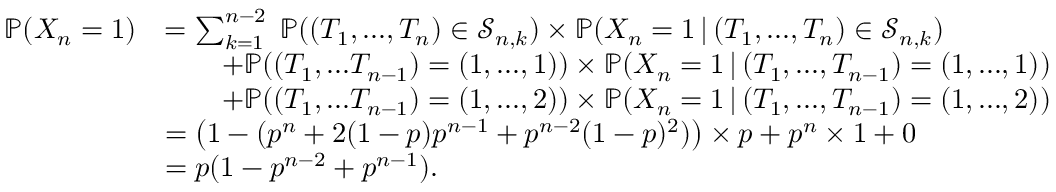<formula> <loc_0><loc_0><loc_500><loc_500>\begin{array} { r l } { \mathbb { P } ( X _ { n } = 1 ) } & { = \sum _ { k = 1 } ^ { n - 2 } \, \mathbb { P } ( ( T _ { 1 } , \dots , T _ { n } ) \in \mathcal { S } _ { n , k } ) \times \mathbb { P } ( X _ { n } = 1 \, | \, ( T _ { 1 } , \dots , T _ { n } ) \in \mathcal { S } _ { n , k } ) } \\ & { \quad + \mathbb { P } ( ( T _ { 1 } , \dots T _ { n - 1 } ) = ( 1 , \dots , 1 ) ) \times \mathbb { P } ( X _ { n } = 1 \, | \, ( T _ { 1 } , \dots , T _ { n - 1 } ) = ( 1 , \dots , 1 ) ) } \\ & { \quad + \mathbb { P } ( ( T _ { 1 } , \dots T _ { n - 1 } ) = ( 1 , \dots , 2 ) ) \times \mathbb { P } ( X _ { n } = 1 \, | \, ( T _ { 1 } , \dots , T _ { n - 1 } ) = ( 1 , \dots , 2 ) ) } \\ & { = \left ( 1 - ( p ^ { n } + 2 ( 1 - p ) p ^ { n - 1 } + p ^ { n - 2 } ( 1 - p ) ^ { 2 } ) \right ) \times p + p ^ { n } \times 1 + 0 } \\ & { = p ( 1 - p ^ { n - 2 } + p ^ { n - 1 } ) . } \end{array}</formula> 